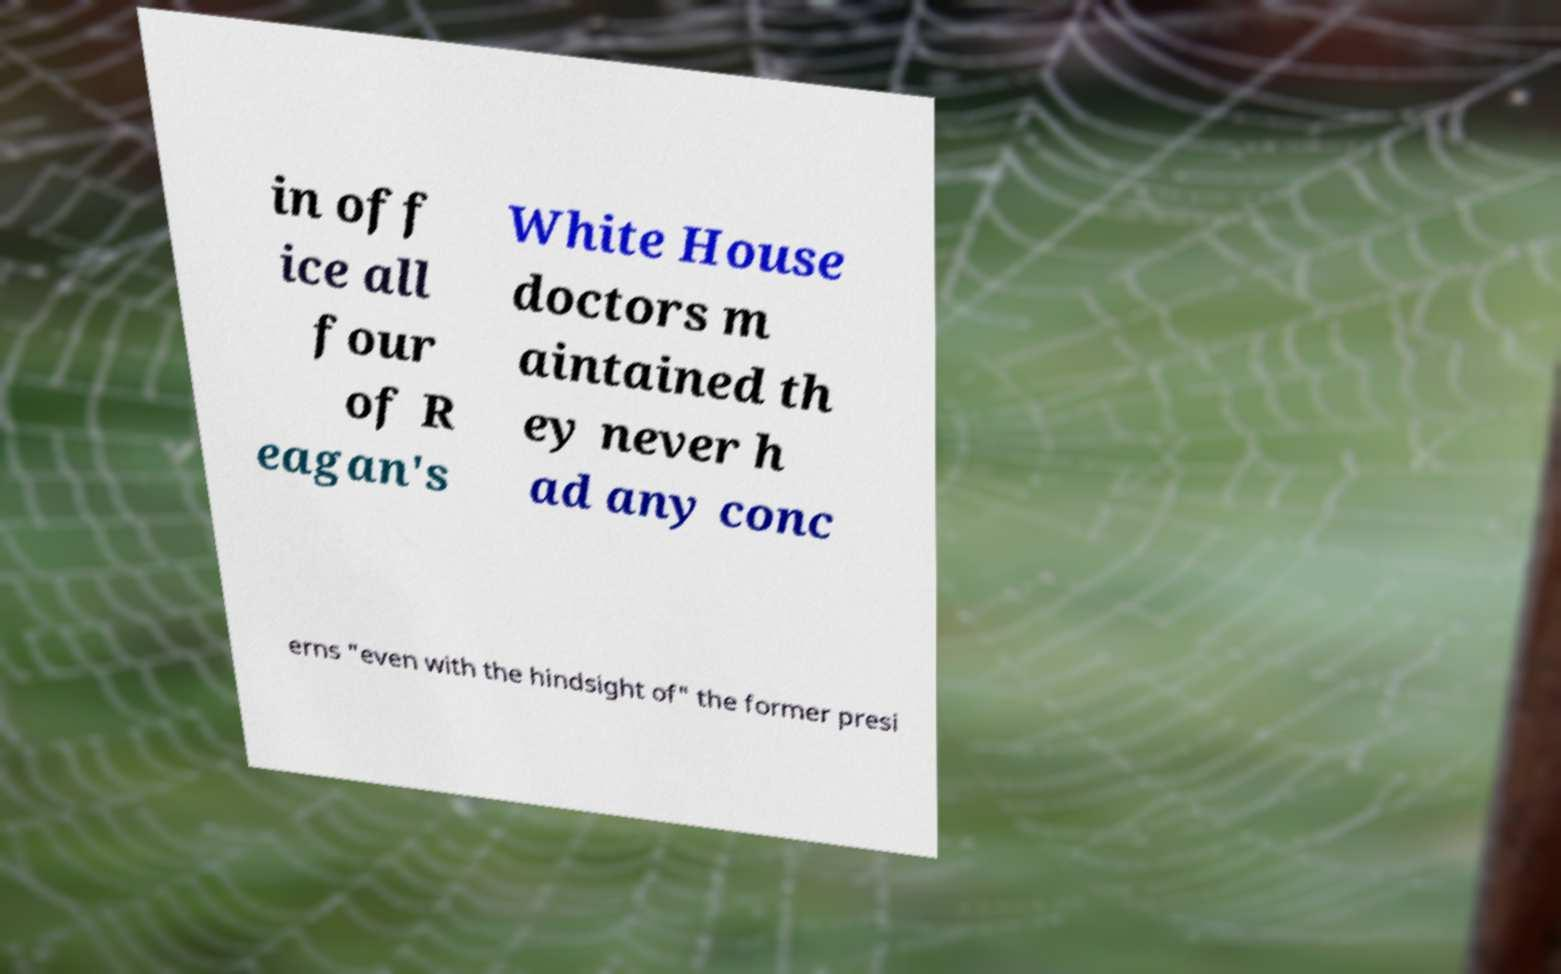Can you accurately transcribe the text from the provided image for me? in off ice all four of R eagan's White House doctors m aintained th ey never h ad any conc erns "even with the hindsight of" the former presi 